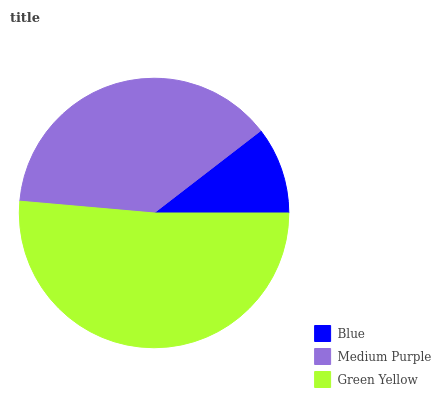Is Blue the minimum?
Answer yes or no. Yes. Is Green Yellow the maximum?
Answer yes or no. Yes. Is Medium Purple the minimum?
Answer yes or no. No. Is Medium Purple the maximum?
Answer yes or no. No. Is Medium Purple greater than Blue?
Answer yes or no. Yes. Is Blue less than Medium Purple?
Answer yes or no. Yes. Is Blue greater than Medium Purple?
Answer yes or no. No. Is Medium Purple less than Blue?
Answer yes or no. No. Is Medium Purple the high median?
Answer yes or no. Yes. Is Medium Purple the low median?
Answer yes or no. Yes. Is Blue the high median?
Answer yes or no. No. Is Green Yellow the low median?
Answer yes or no. No. 